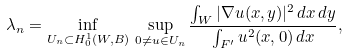<formula> <loc_0><loc_0><loc_500><loc_500>\lambda _ { n } = \inf _ { U _ { n } \subset H _ { 0 } ^ { 1 } ( W , B ) } \, \sup _ { 0 \neq u \in U _ { n } } \frac { \int _ { W } | \nabla u ( x , y ) | ^ { 2 } \, d x \, d y } { \int _ { F ^ { \prime } } u ^ { 2 } ( x , 0 ) \, d x } ,</formula> 